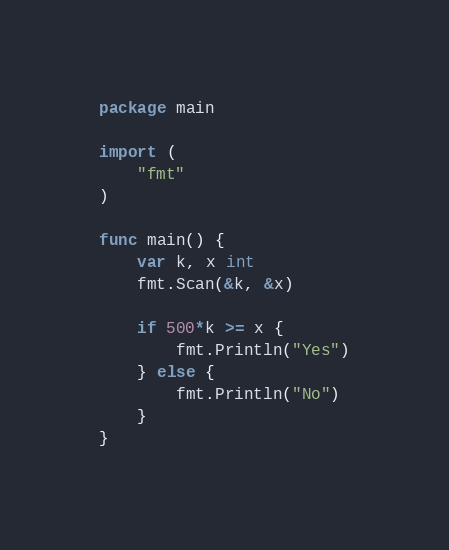<code> <loc_0><loc_0><loc_500><loc_500><_Go_>package main

import (
	"fmt"
)

func main() {
	var k, x int
	fmt.Scan(&k, &x)

	if 500*k >= x {
		fmt.Println("Yes")
	} else {
		fmt.Println("No")
	}
}
</code> 